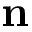<formula> <loc_0><loc_0><loc_500><loc_500>n</formula> 